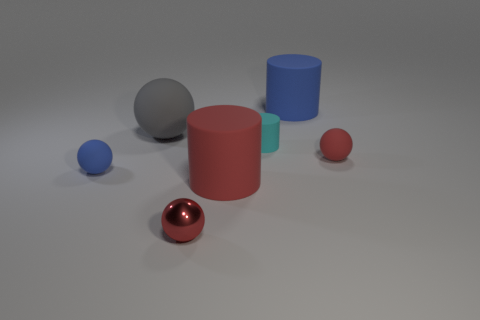Add 2 large red matte cylinders. How many objects exist? 9 Subtract all cylinders. How many objects are left? 4 Subtract all blue matte cylinders. Subtract all big purple shiny spheres. How many objects are left? 6 Add 7 big things. How many big things are left? 10 Add 1 large red cylinders. How many large red cylinders exist? 2 Subtract 0 gray cylinders. How many objects are left? 7 